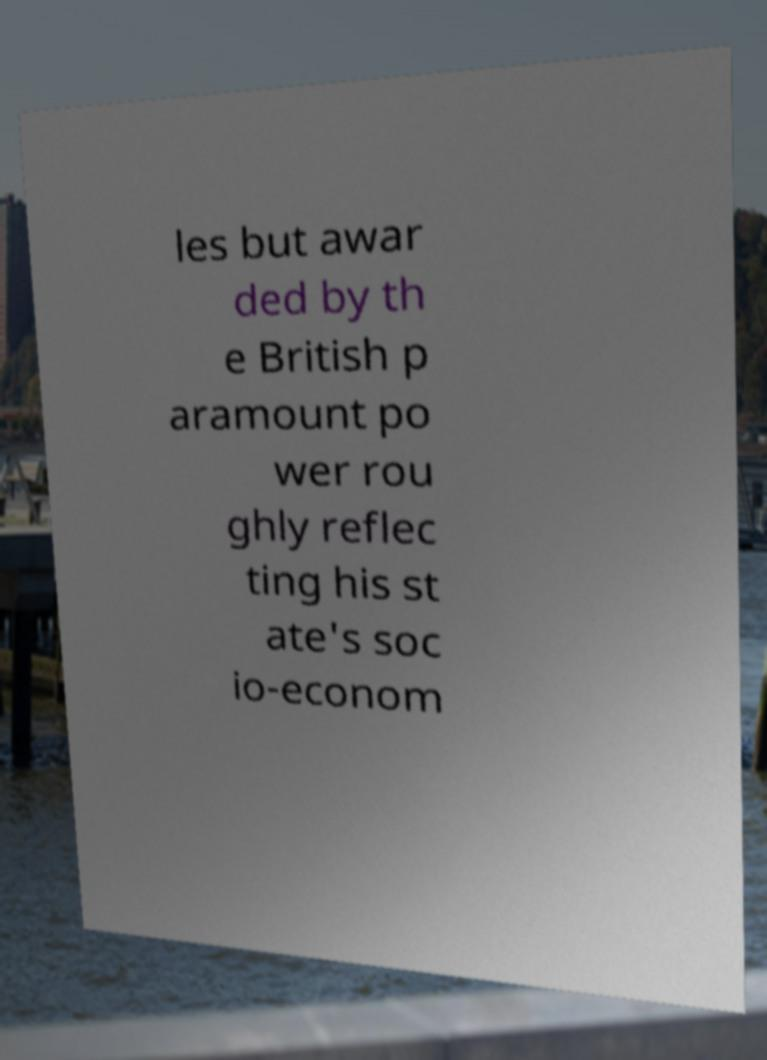I need the written content from this picture converted into text. Can you do that? les but awar ded by th e British p aramount po wer rou ghly reflec ting his st ate's soc io-econom 